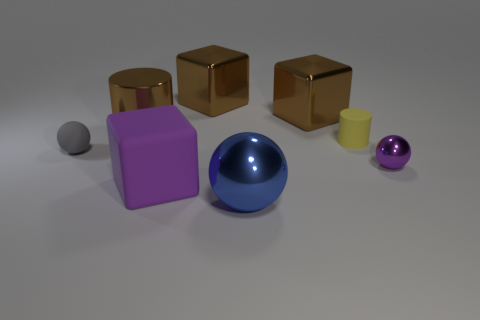Add 2 big shiny things. How many objects exist? 10 Subtract all cylinders. How many objects are left? 6 Subtract 0 cyan cylinders. How many objects are left? 8 Subtract all blue things. Subtract all purple objects. How many objects are left? 5 Add 5 yellow matte cylinders. How many yellow matte cylinders are left? 6 Add 6 small metallic things. How many small metallic things exist? 7 